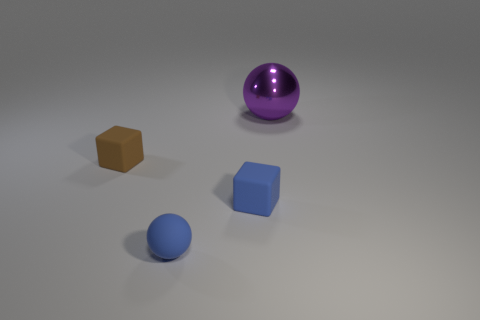Add 2 big purple spheres. How many objects exist? 6 Subtract all blue cubes. How many cubes are left? 1 Subtract 1 balls. How many balls are left? 1 Add 4 purple shiny cylinders. How many purple shiny cylinders exist? 4 Subtract 0 red cubes. How many objects are left? 4 Subtract all green blocks. Subtract all blue cylinders. How many blocks are left? 2 Subtract all large purple cylinders. Subtract all spheres. How many objects are left? 2 Add 2 big purple metal objects. How many big purple metal objects are left? 3 